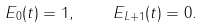<formula> <loc_0><loc_0><loc_500><loc_500>E _ { 0 } ( t ) = 1 , \quad E _ { L + 1 } ( t ) = 0 .</formula> 